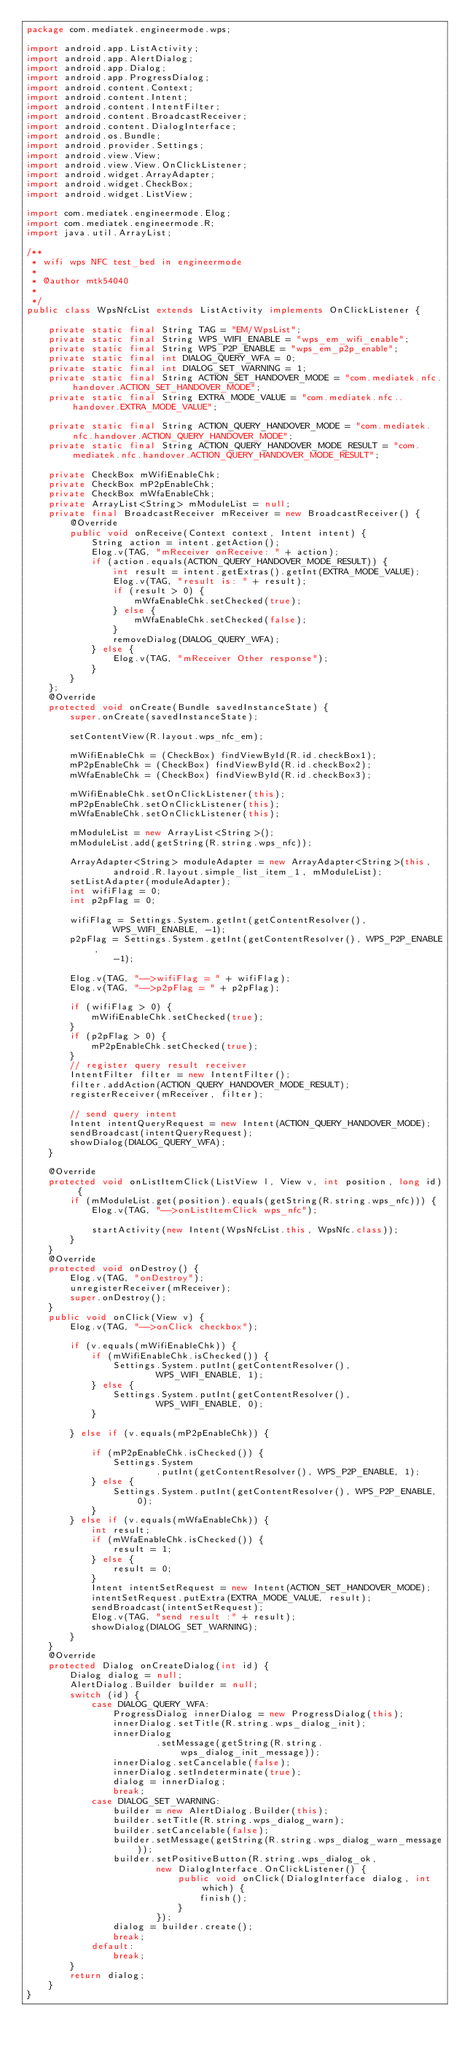Convert code to text. <code><loc_0><loc_0><loc_500><loc_500><_Java_>package com.mediatek.engineermode.wps;

import android.app.ListActivity;
import android.app.AlertDialog;
import android.app.Dialog;
import android.app.ProgressDialog;
import android.content.Context;
import android.content.Intent;
import android.content.IntentFilter;
import android.content.BroadcastReceiver;
import android.content.DialogInterface;
import android.os.Bundle;
import android.provider.Settings;
import android.view.View;
import android.view.View.OnClickListener;
import android.widget.ArrayAdapter;
import android.widget.CheckBox;
import android.widget.ListView;

import com.mediatek.engineermode.Elog;
import com.mediatek.engineermode.R;
import java.util.ArrayList;

/**
 * wifi wps NFC test_bed in engineermode
 *
 * @author mtk54040
 *
 */
public class WpsNfcList extends ListActivity implements OnClickListener {

    private static final String TAG = "EM/WpsList";
    private static final String WPS_WIFI_ENABLE = "wps_em_wifi_enable";
    private static final String WPS_P2P_ENABLE = "wps_em_p2p_enable";
    private static final int DIALOG_QUERY_WFA = 0;
    private static final int DIALOG_SET_WARNING = 1;
    private static final String ACTION_SET_HANDOVER_MODE = "com.mediatek.nfc.handover.ACTION_SET_HANDOVER_MODE";
    private static final String EXTRA_MODE_VALUE = "com.mediatek.nfc..handover.EXTRA_MODE_VALUE";

    private static final String ACTION_QUERY_HANDOVER_MODE = "com.mediatek.nfc.handover.ACTION_QUERY_HANDOVER_MODE";
    private static final String ACTION_QUERY_HANDOVER_MODE_RESULT = "com.mediatek.nfc.handover.ACTION_QUERY_HANDOVER_MODE_RESULT";

    private CheckBox mWifiEnableChk;
    private CheckBox mP2pEnableChk;
    private CheckBox mWfaEnableChk;
    private ArrayList<String> mModuleList = null;
    private final BroadcastReceiver mReceiver = new BroadcastReceiver() {
        @Override
        public void onReceive(Context context, Intent intent) {
            String action = intent.getAction();
            Elog.v(TAG, "mReceiver onReceive: " + action);
            if (action.equals(ACTION_QUERY_HANDOVER_MODE_RESULT)) {
                int result = intent.getExtras().getInt(EXTRA_MODE_VALUE);
                Elog.v(TAG, "result is: " + result);
                if (result > 0) {
                    mWfaEnableChk.setChecked(true);
                } else {
                    mWfaEnableChk.setChecked(false);
                }
                removeDialog(DIALOG_QUERY_WFA);
            } else {
                Elog.v(TAG, "mReceiver Other response");
            }
        }
    };
    @Override
    protected void onCreate(Bundle savedInstanceState) {
        super.onCreate(savedInstanceState);

        setContentView(R.layout.wps_nfc_em);

        mWifiEnableChk = (CheckBox) findViewById(R.id.checkBox1);
        mP2pEnableChk = (CheckBox) findViewById(R.id.checkBox2);
        mWfaEnableChk = (CheckBox) findViewById(R.id.checkBox3);

        mWifiEnableChk.setOnClickListener(this);
        mP2pEnableChk.setOnClickListener(this);
        mWfaEnableChk.setOnClickListener(this);

        mModuleList = new ArrayList<String>();
        mModuleList.add(getString(R.string.wps_nfc));

        ArrayAdapter<String> moduleAdapter = new ArrayAdapter<String>(this,
                android.R.layout.simple_list_item_1, mModuleList);
        setListAdapter(moduleAdapter);
        int wifiFlag = 0;
        int p2pFlag = 0;

        wifiFlag = Settings.System.getInt(getContentResolver(),
                WPS_WIFI_ENABLE, -1);
        p2pFlag = Settings.System.getInt(getContentResolver(), WPS_P2P_ENABLE,
                -1);

        Elog.v(TAG, "-->wifiFlag = " + wifiFlag);
        Elog.v(TAG, "-->p2pFlag = " + p2pFlag);

        if (wifiFlag > 0) {
            mWifiEnableChk.setChecked(true);
        }
        if (p2pFlag > 0) {
            mP2pEnableChk.setChecked(true);
        }
        // register query result receiver
        IntentFilter filter = new IntentFilter();
        filter.addAction(ACTION_QUERY_HANDOVER_MODE_RESULT);
        registerReceiver(mReceiver, filter);

        // send query intent
        Intent intentQueryRequest = new Intent(ACTION_QUERY_HANDOVER_MODE);
        sendBroadcast(intentQueryRequest);
        showDialog(DIALOG_QUERY_WFA);
    }

    @Override
    protected void onListItemClick(ListView l, View v, int position, long id) {
        if (mModuleList.get(position).equals(getString(R.string.wps_nfc))) {
            Elog.v(TAG, "-->onListItemClick wps_nfc");

            startActivity(new Intent(WpsNfcList.this, WpsNfc.class));
        }
    }
    @Override
    protected void onDestroy() {
        Elog.v(TAG, "onDestroy");
        unregisterReceiver(mReceiver);
        super.onDestroy();
    }
    public void onClick(View v) {
        Elog.v(TAG, "-->onClick checkbox");

        if (v.equals(mWifiEnableChk)) {
            if (mWifiEnableChk.isChecked()) {
                Settings.System.putInt(getContentResolver(),
                        WPS_WIFI_ENABLE, 1);
            } else {
                Settings.System.putInt(getContentResolver(),
                        WPS_WIFI_ENABLE, 0);
            }

        } else if (v.equals(mP2pEnableChk)) {

            if (mP2pEnableChk.isChecked()) {
                Settings.System
                        .putInt(getContentResolver(), WPS_P2P_ENABLE, 1);
            } else {
                Settings.System.putInt(getContentResolver(), WPS_P2P_ENABLE, 0);
            }
        } else if (v.equals(mWfaEnableChk)) {
            int result;
            if (mWfaEnableChk.isChecked()) {
                result = 1;
            } else {
                result = 0;
            }
            Intent intentSetRequest = new Intent(ACTION_SET_HANDOVER_MODE);
            intentSetRequest.putExtra(EXTRA_MODE_VALUE, result);
            sendBroadcast(intentSetRequest);
            Elog.v(TAG, "send result :" + result);
            showDialog(DIALOG_SET_WARNING);
        }
    }
    @Override
    protected Dialog onCreateDialog(int id) {
        Dialog dialog = null;
        AlertDialog.Builder builder = null;
        switch (id) {
            case DIALOG_QUERY_WFA:
                ProgressDialog innerDialog = new ProgressDialog(this);
                innerDialog.setTitle(R.string.wps_dialog_init);
                innerDialog
                        .setMessage(getString(R.string.wps_dialog_init_message));
                innerDialog.setCancelable(false);
                innerDialog.setIndeterminate(true);
                dialog = innerDialog;
                break;
            case DIALOG_SET_WARNING:
                builder = new AlertDialog.Builder(this);
                builder.setTitle(R.string.wps_dialog_warn);
                builder.setCancelable(false);
                builder.setMessage(getString(R.string.wps_dialog_warn_message));
                builder.setPositiveButton(R.string.wps_dialog_ok,
                        new DialogInterface.OnClickListener() {
                            public void onClick(DialogInterface dialog, int which) {
                                finish();
                            }
                        });
                dialog = builder.create();
                break;
            default:
                break;
        }
        return dialog;
    }
}
</code> 